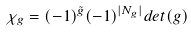<formula> <loc_0><loc_0><loc_500><loc_500>\chi _ { g } = ( - 1 ) ^ { \tilde { g } } ( - 1 ) ^ { | N _ { g } | } d e t ( g )</formula> 